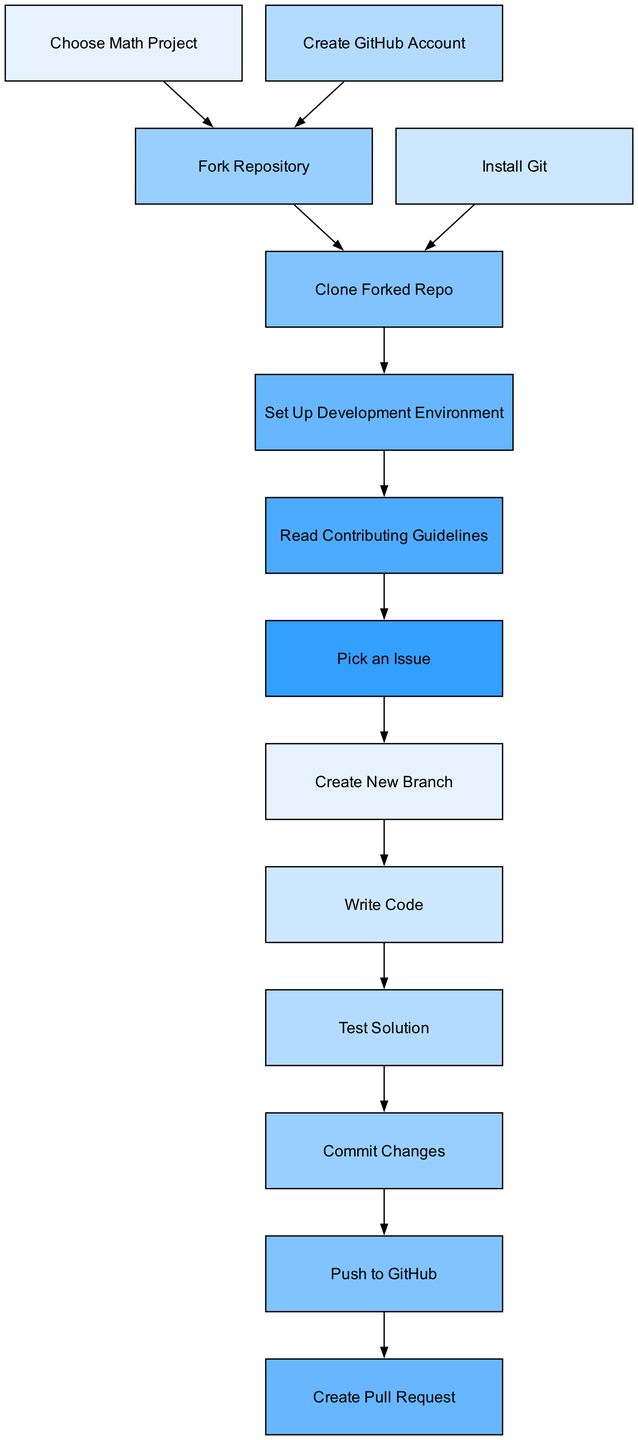What is the starting node in the workflow? The starting point in the diagram is represented by the node "Choose Math Project," which is where the process begins.
Answer: Choose Math Project How many nodes are there in the diagram? To find the total number of nodes, we can count each unique step listed in the diagram. There are 13 nodes in total.
Answer: 13 What is the last node in the process? The final node in the workflow is "Create Pull Request," indicating the end of the contribution process to the project.
Answer: Create Pull Request What is the direct predecessor of "Write Code"? The node directly leading to "Write Code" is "Create New Branch," which shows the immediate step before writing code.
Answer: Create New Branch How many edges are there in total? By examining the connections between the nodes, we can count the edges connecting them. There are 12 edges in total.
Answer: 12 What are the two nodes that come before "Push to GitHub"? The two direct predecessors leading to "Push to GitHub" are "Commit Changes" and "Test Solution," which must occur prior to pushing.
Answer: Commit Changes, Test Solution Is it necessary to read the contributing guidelines before picking an issue? Yes, the diagram indicates that "Read Contributing Guidelines" must occur before "Pick an Issue," establishing a required order.
Answer: Yes How many steps are there from starting to creating a pull request? Starting from "Choose Math Project" to "Create Pull Request," there are 7 steps in between, reflecting the necessary actions to reach that point.
Answer: 7 Which node follows "Fork Repository"? The node that directly follows "Fork Repository" in the workflow is "Clone Forked Repo," showing the immediate next action after forking.
Answer: Clone Forked Repo 